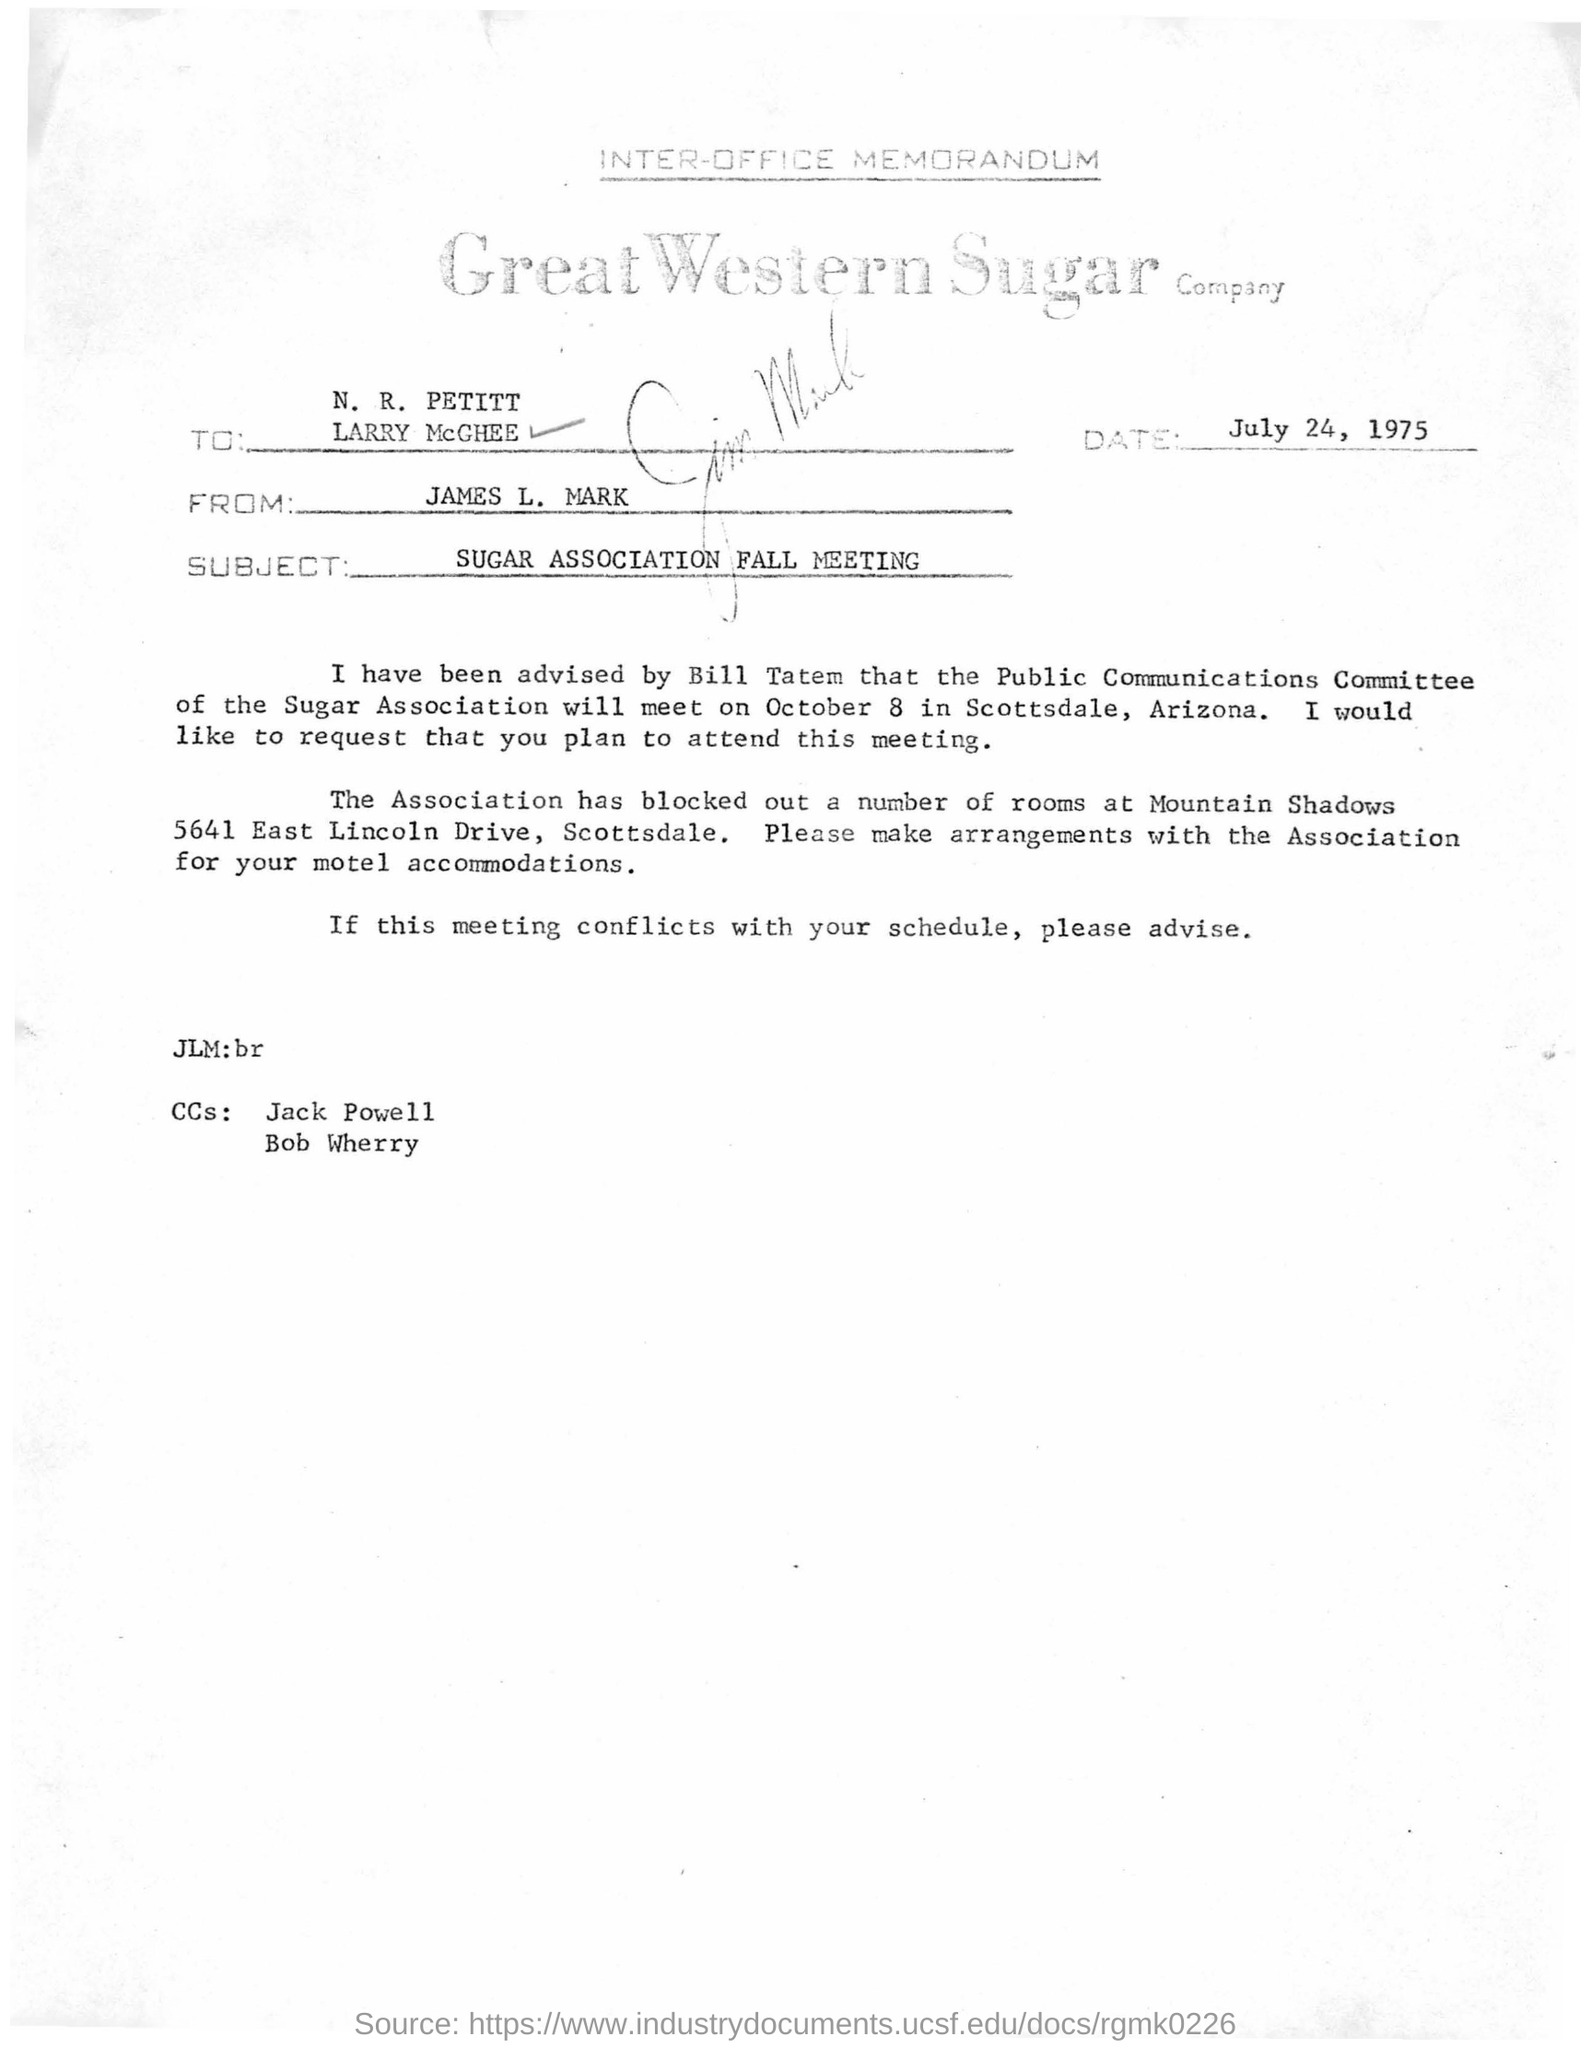What kind of memorandum is this ?
Your answer should be compact. INTER-OFFICE MEMORANDUM. Who is the sender of this memorandum?
Keep it short and to the point. JAMES L. MARK. What is the date mentioned in the memorandum?
Offer a terse response. July 24, 1975. 